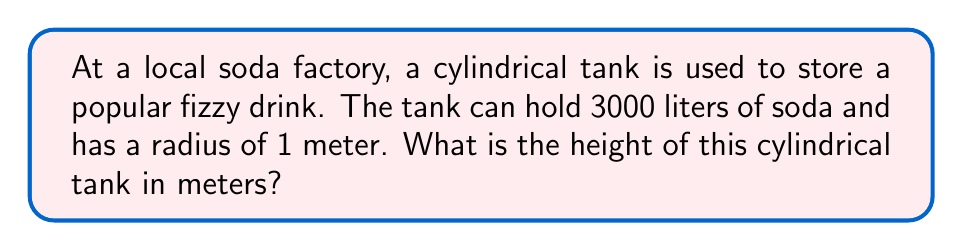What is the answer to this math problem? Let's approach this step-by-step:

1) First, we need to recall the formula for the volume of a cylinder:
   $$ V = \pi r^2 h $$
   where $V$ is volume, $r$ is radius, and $h$ is height.

2) We're given the volume and radius:
   - Volume (V) = 3000 liters
   - Radius (r) = 1 meter

3) However, we need to convert the volume to cubic meters:
   $$ 3000 \text{ liters} = 3 \text{ m}^3 $$

4) Now we can substitute these values into our formula:
   $$ 3 = \pi (1)^2 h $$

5) Simplify:
   $$ 3 = \pi h $$

6) To find $h$, we divide both sides by $\pi$:
   $$ h = \frac{3}{\pi} $$

7) Using a calculator or approximating $\pi$ as 3.14159:
   $$ h \approx 0.95493 \text{ meters} $$

Thus, the height of the cylindrical tank is approximately 0.95493 meters.
Answer: $0.95493 \text{ m}$ 